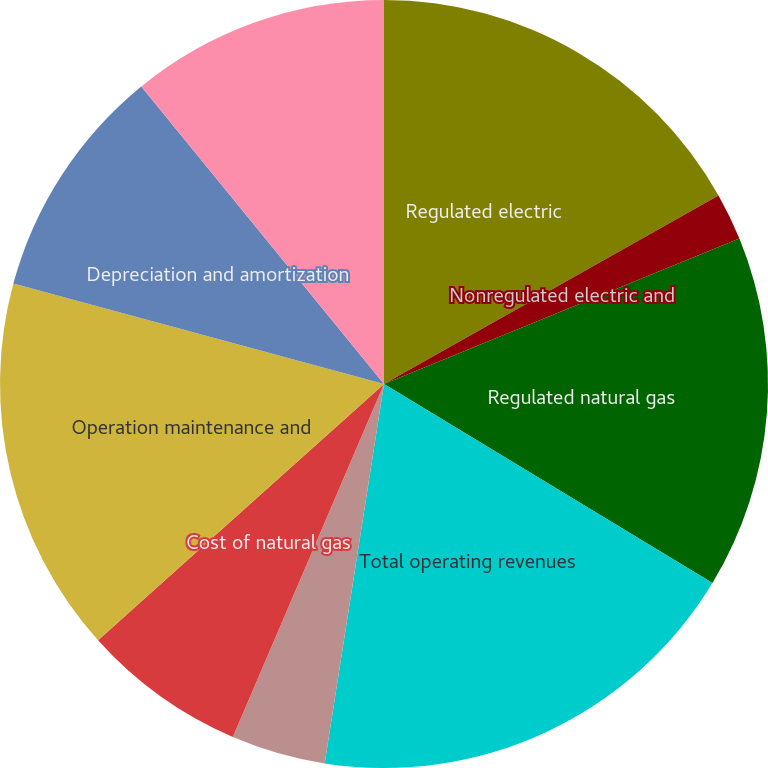Convert chart. <chart><loc_0><loc_0><loc_500><loc_500><pie_chart><fcel>Regulated electric<fcel>Nonregulated electric and<fcel>Regulated natural gas<fcel>Total operating revenues<fcel>Fuel used in electric<fcel>Cost of natural gas<fcel>Operation maintenance and<fcel>Depreciation and amortization<fcel>Property and other taxes<nl><fcel>16.83%<fcel>1.99%<fcel>14.85%<fcel>18.8%<fcel>3.97%<fcel>6.93%<fcel>15.84%<fcel>9.9%<fcel>10.89%<nl></chart> 